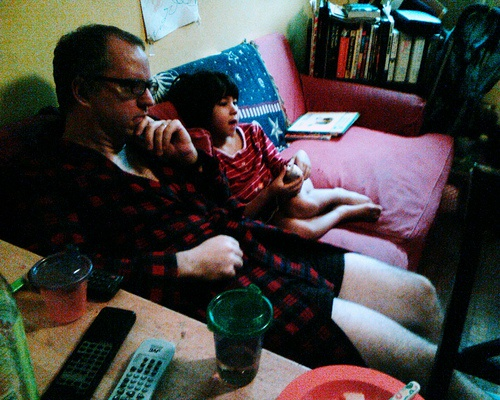Describe the objects in this image and their specific colors. I can see people in gray, black, darkgray, maroon, and lavender tones, couch in gray, violet, black, and maroon tones, people in gray, black, maroon, lavender, and darkgray tones, cup in gray, black, darkgreen, teal, and navy tones, and remote in gray, black, maroon, navy, and olive tones in this image. 